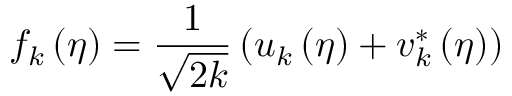Convert formula to latex. <formula><loc_0><loc_0><loc_500><loc_500>f _ { k } \left ( \eta \right ) = \frac { 1 } { \sqrt { 2 k } } \left ( u _ { k } \left ( \eta \right ) + v _ { k } ^ { \ast } \left ( \eta \right ) \right )</formula> 